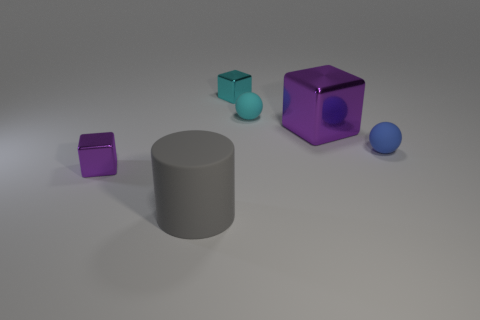Subtract all big purple metal cubes. How many cubes are left? 2 Subtract all cyan blocks. How many blocks are left? 2 Subtract all brown cylinders. How many purple blocks are left? 2 Add 3 cyan things. How many objects exist? 9 Subtract all spheres. How many objects are left? 4 Subtract all yellow spheres. Subtract all yellow cubes. How many spheres are left? 2 Subtract all small brown cylinders. Subtract all rubber cylinders. How many objects are left? 5 Add 4 small blue matte balls. How many small blue matte balls are left? 5 Add 3 small things. How many small things exist? 7 Subtract 0 green balls. How many objects are left? 6 